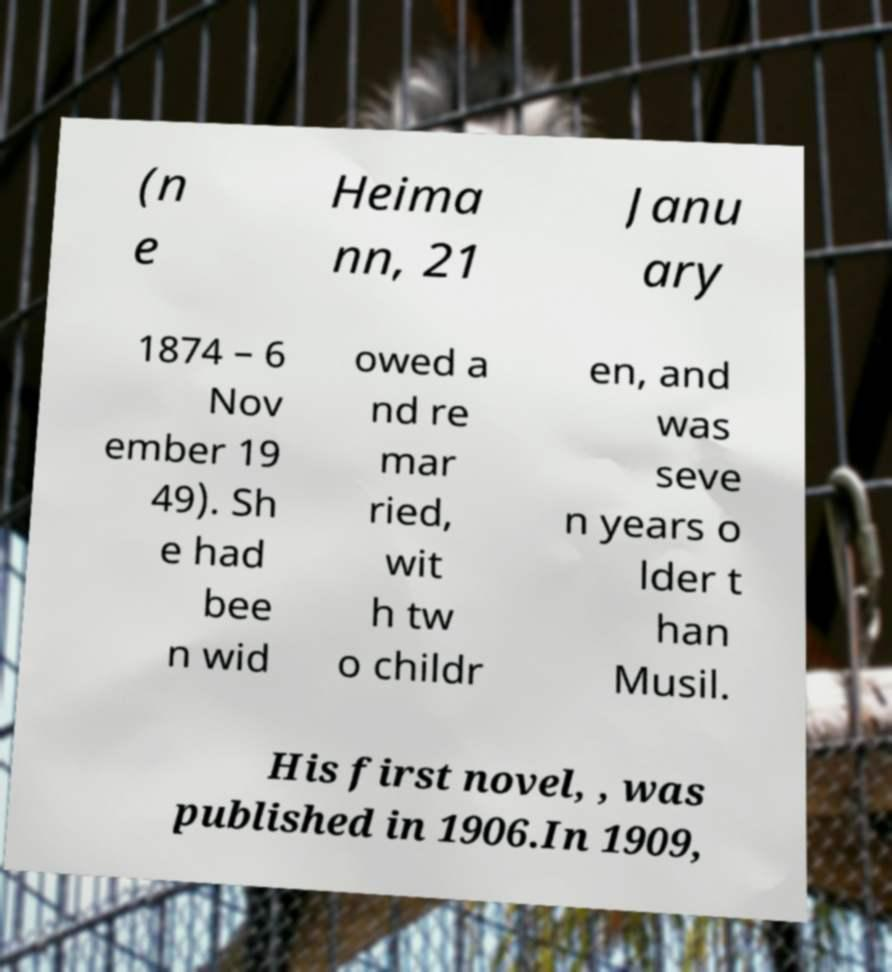For documentation purposes, I need the text within this image transcribed. Could you provide that? (n e Heima nn, 21 Janu ary 1874 – 6 Nov ember 19 49). Sh e had bee n wid owed a nd re mar ried, wit h tw o childr en, and was seve n years o lder t han Musil. His first novel, , was published in 1906.In 1909, 